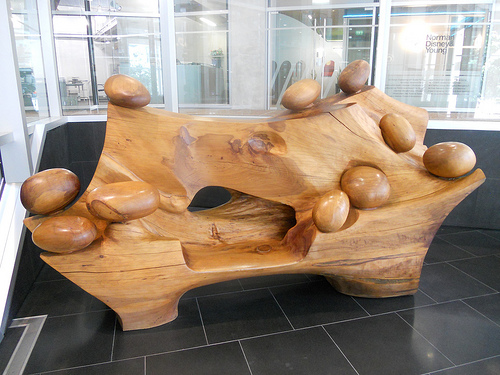<image>
Is there a bench behind the window? No. The bench is not behind the window. From this viewpoint, the bench appears to be positioned elsewhere in the scene. 